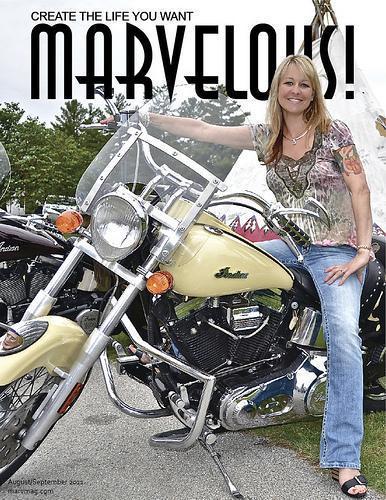How many flying bikes are there in the image?
Give a very brief answer. 1. 